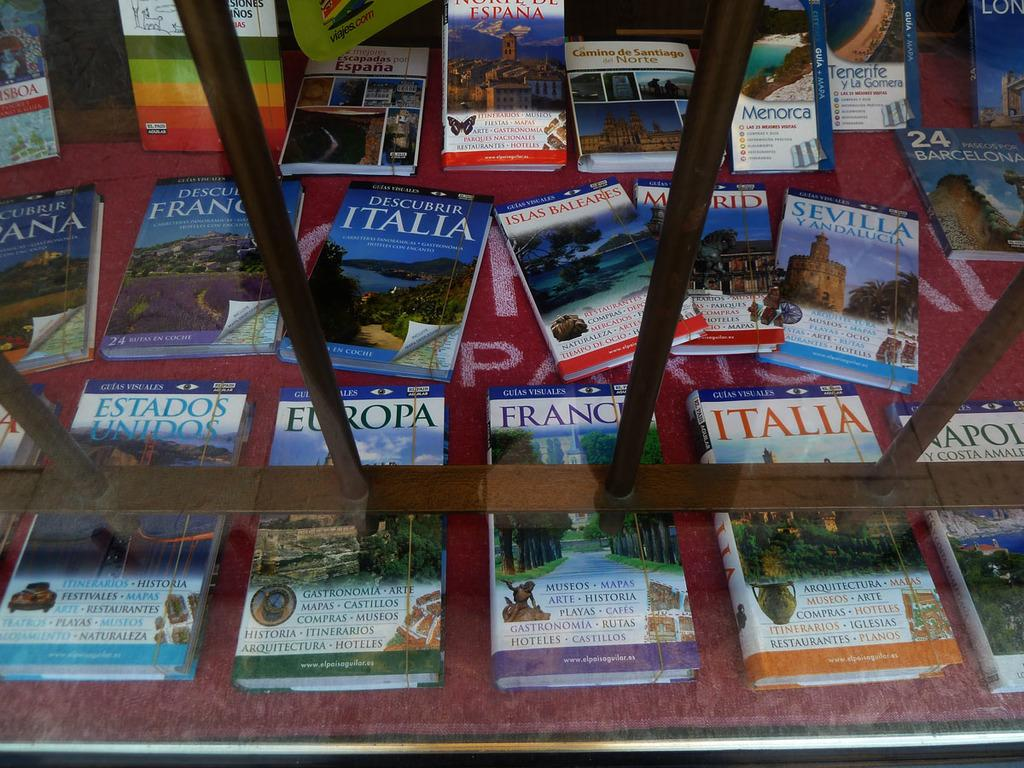<image>
Share a concise interpretation of the image provided. Guide books for France, Italia, and Europa sit on display in a shop 